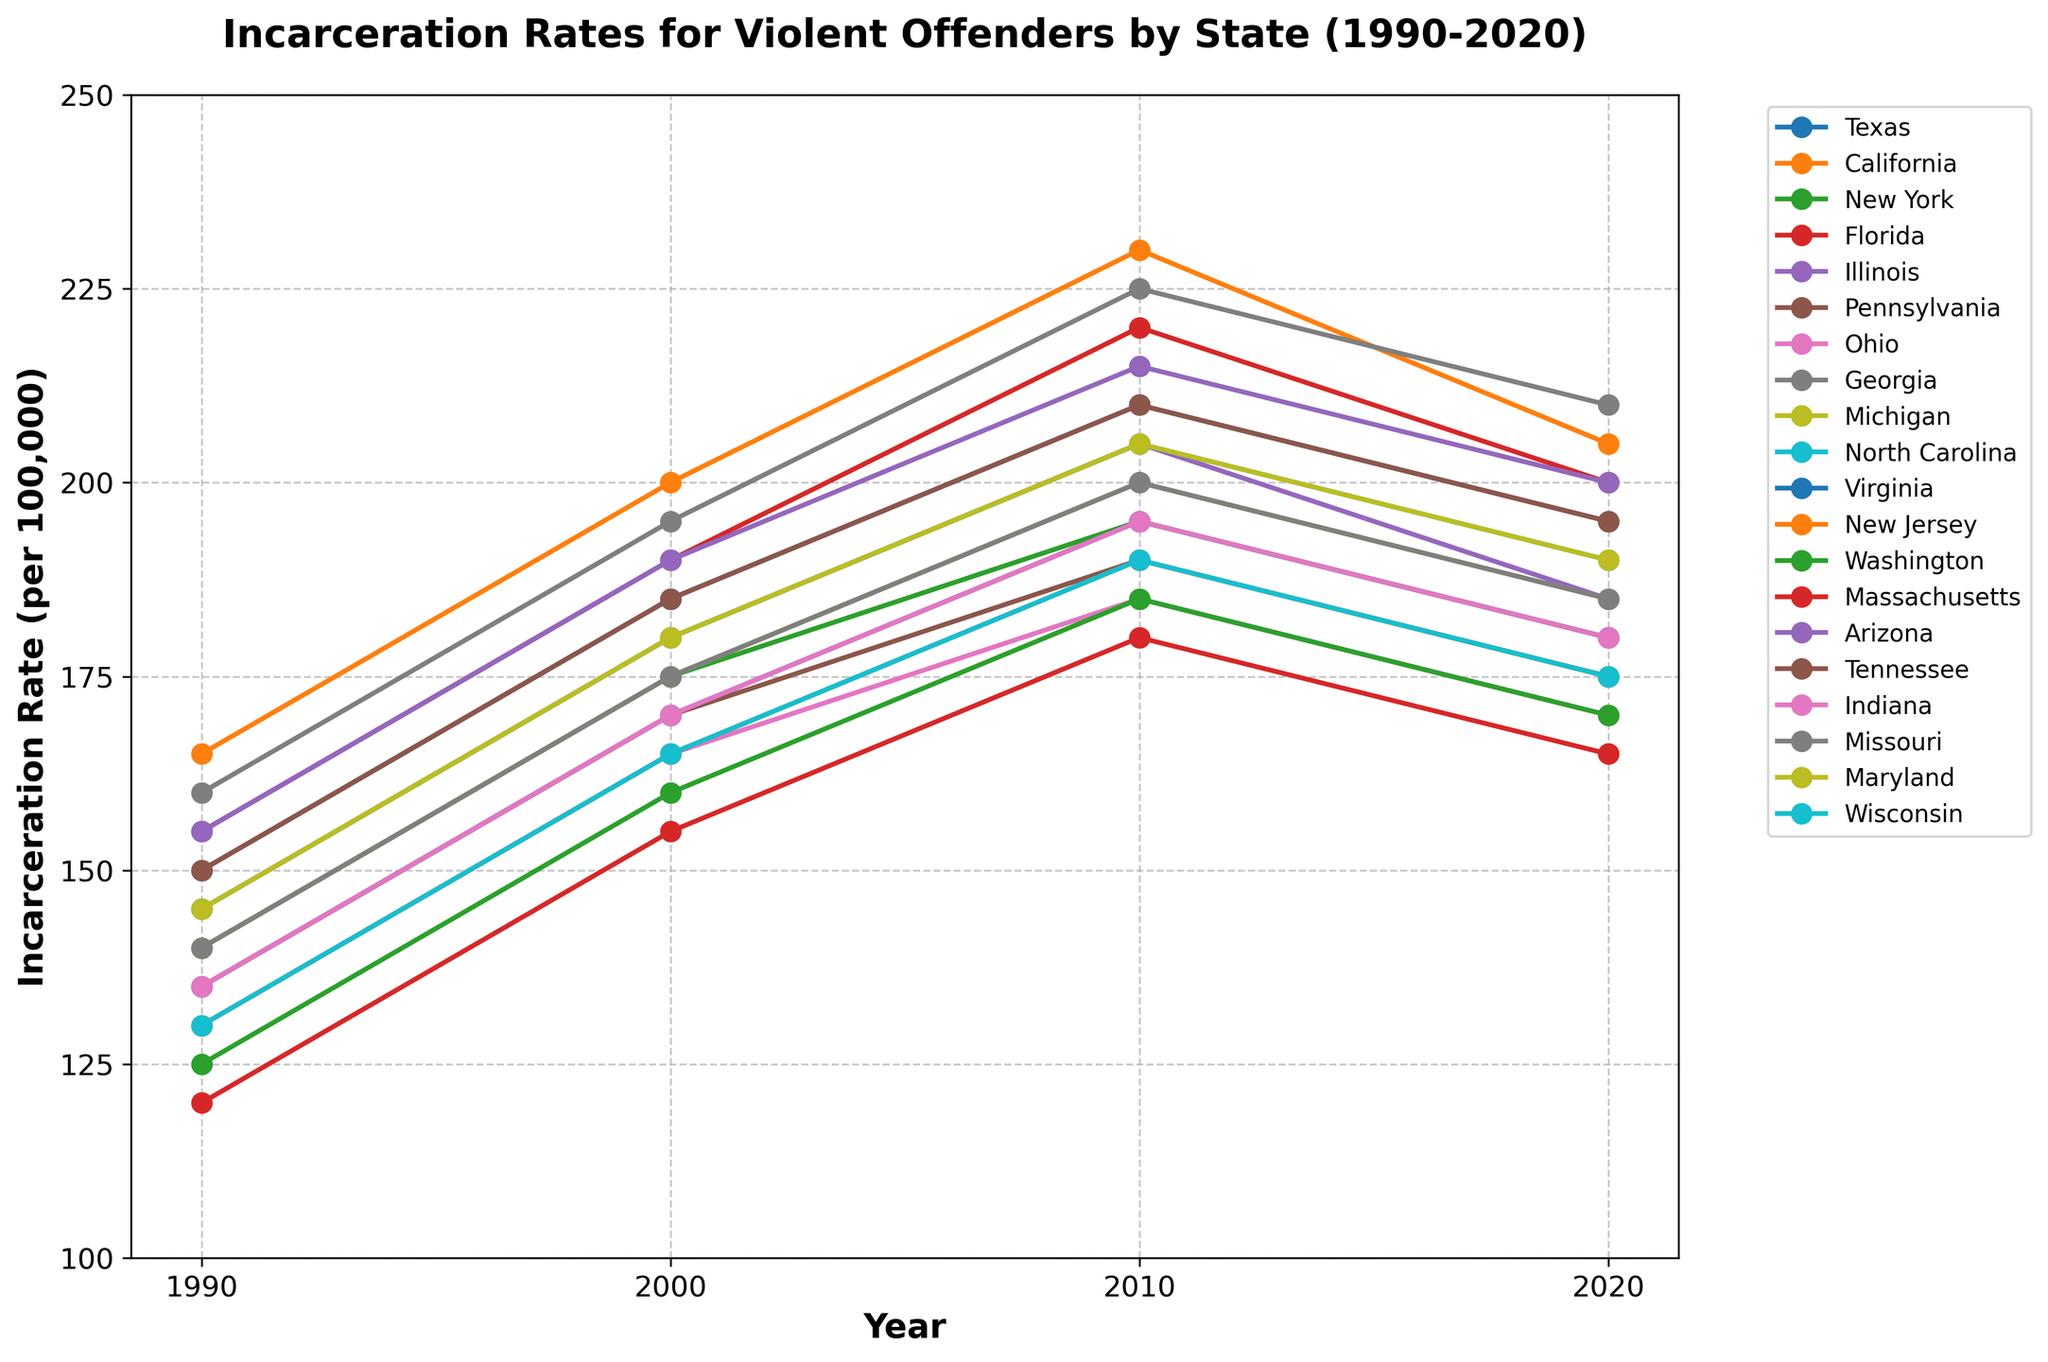What's the highest incarceration rate observed in the figure? To find the highest incarceration rate, visually inspect the peaks of the lines from different states over the four recorded years (1990, 2000, 2010, 2020). The highest peak is for California in 2010 at 230 per 100,000.
Answer: 230 per 100,000 Which two states had the same incarceration rate in 1990, and what was it? From the lines plotted, we need to find where two lines intersect on the 1990 vertical line. Texas and Tennessee both have a rate of 150 per 100,000 in 1990.
Answer: Texas and Tennessee, 150 per 100,000 Which state experienced the smallest increase in incarceration rate from 1990 to 2020? Look at the difference between the incarceration rates in 1990 and 2020 for each state. Massachusetts had an increase from 120 in 1990 to 165 in 2020, an increase of 45, which is the smallest among all states.
Answer: Massachusetts What is the combined incarceration rate for New York and Ohio in 2020? Find the values for New York and Ohio in 2020, which are 180 and 170 respectively, then sum them: 180 + 170 = 350.
Answer: 350 per 100,000 By how much did the incarceration rate for Florida change from 2000 to 2020? Look at the values for Florida in 2000 and 2020. In 2000, it was 190, and in 2020, it was 200. The change is 200 - 190 = 10.
Answer: 10 per 100,000 Which state had the lowest incarceration rate in 1990, and what was the rate? Visually inspect the lines for the year 1990 and identify the lowest mark. Massachusetts had the lowest rate at 120 per 100,000.
Answer: Massachusetts, 120 per 100,000 Did any state have a decreasing trend in incarceration rates from 2010 to 2020? Check the slope of each line between the points for 2010 and 2020. All states except California, Texas, Florida, Virginia, and Michigan show a decrease, with incarceration rates falling from 230 to 205 for California, 210 to 195 for Texas, etc.
Answer: Yes What is the average incarceration rate across all states in 2010? Sum the incarceration rates for all states in 2010 and divide by the number of states. (210 + 230 + 195 + 220 + 205 + 190 + 185 + 225 + 200 + 205 + 195 + 190 + 185 + 180 + 215 + 210 + 195 + 200 + 205 + 190) / 20 = 199.5.
Answer: 199.5 per 100,000 Which state showed the most significant decline in incarceration rates between 2010 and 2020? Calculate the difference between the 2010 and 2020 rates for each state. California, with a drop from 230 in 2010 to 205 in 2020, has the most significant decline of 25.
Answer: California How does the incarceration rate of Georgia in 2020 compare to that of Indiana in the same year? Identify the values for Georgia and Indiana in 2020. Georgia's rate is 210 and Indiana's rate is 180. Thus, Georgia's rate is higher.
Answer: Georgia's rate is higher 